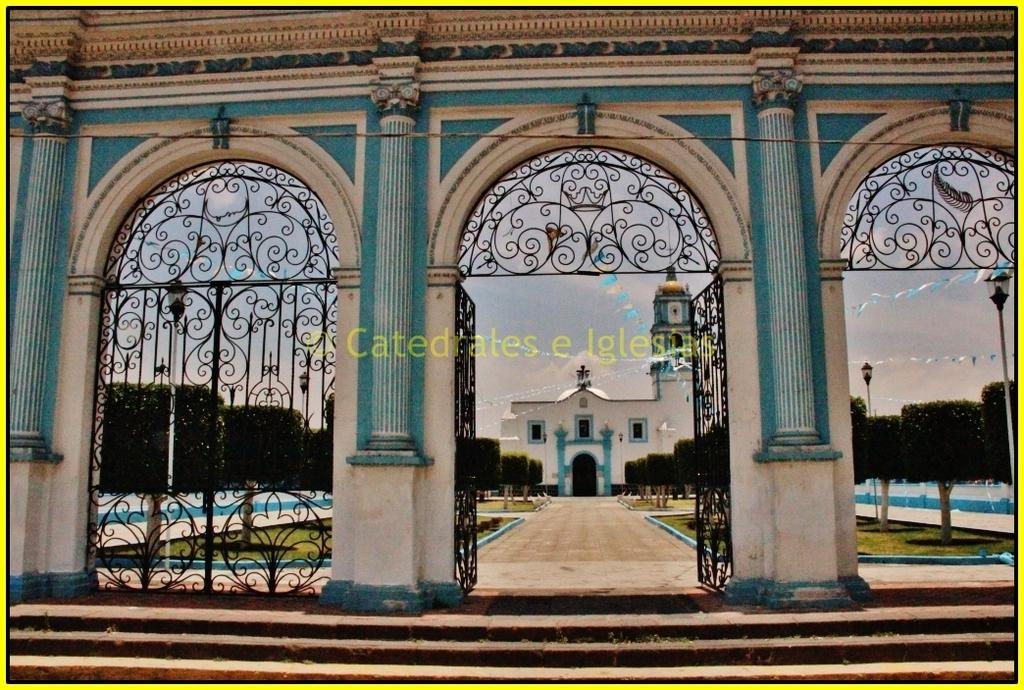What structure can be seen in the image? There is a gate in the image. What else is present in the image besides the gate? There is a building, grass, trees, and steps visible in the image. What can be seen in the background of the image? The sky is visible in the background of the image. Is there any indication of a watermark in the image? Yes, there is a watermark in the image. What type of cord is being used to mark the territory in the image? There is no cord or territory present in the image; it features a gate, a building, grass, trees, steps, the sky, and a watermark. Can you tell me the name of the father in the image? There is no person or father present in the image. 